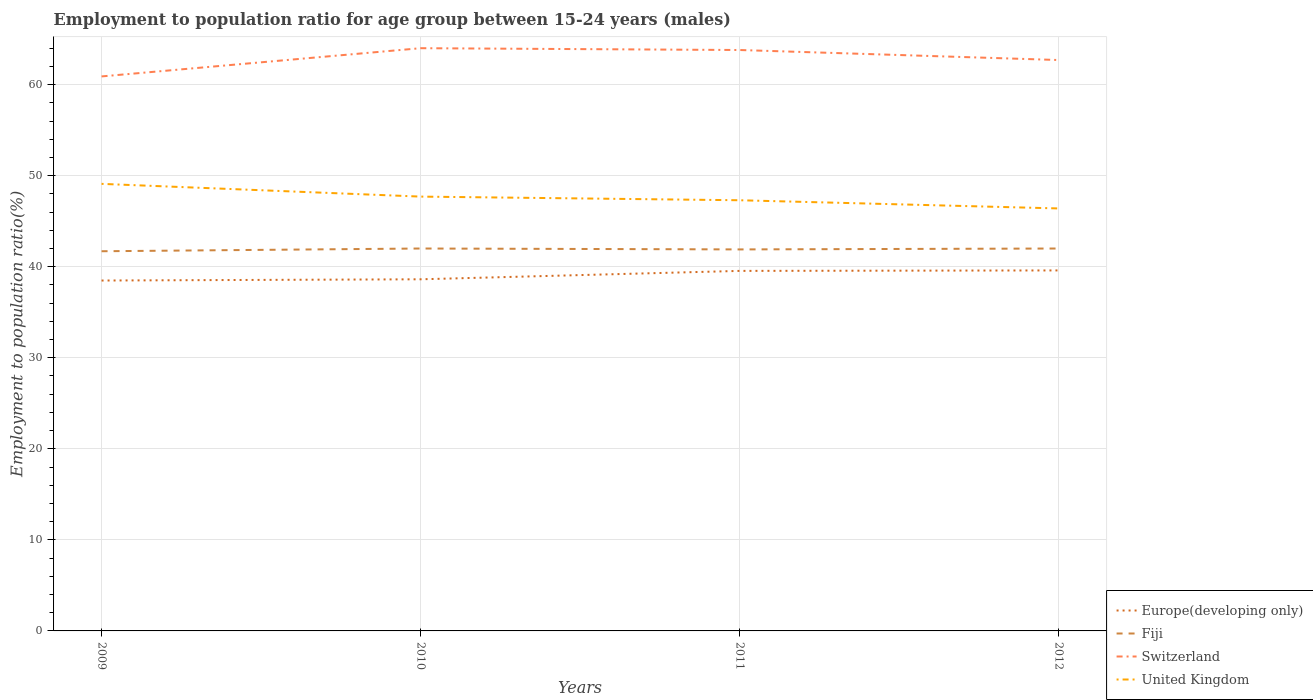Does the line corresponding to Switzerland intersect with the line corresponding to Fiji?
Your answer should be very brief. No. Across all years, what is the maximum employment to population ratio in Europe(developing only)?
Provide a succinct answer. 38.48. In which year was the employment to population ratio in Fiji maximum?
Keep it short and to the point. 2009. What is the total employment to population ratio in Europe(developing only) in the graph?
Give a very brief answer. -0.97. What is the difference between the highest and the second highest employment to population ratio in Fiji?
Your answer should be compact. 0.3. What is the difference between the highest and the lowest employment to population ratio in United Kingdom?
Offer a very short reply. 2. Are the values on the major ticks of Y-axis written in scientific E-notation?
Offer a very short reply. No. Does the graph contain grids?
Give a very brief answer. Yes. How are the legend labels stacked?
Your response must be concise. Vertical. What is the title of the graph?
Make the answer very short. Employment to population ratio for age group between 15-24 years (males). Does "Bolivia" appear as one of the legend labels in the graph?
Ensure brevity in your answer.  No. What is the label or title of the X-axis?
Offer a very short reply. Years. What is the Employment to population ratio(%) of Europe(developing only) in 2009?
Provide a succinct answer. 38.48. What is the Employment to population ratio(%) in Fiji in 2009?
Your answer should be very brief. 41.7. What is the Employment to population ratio(%) in Switzerland in 2009?
Give a very brief answer. 60.9. What is the Employment to population ratio(%) of United Kingdom in 2009?
Provide a short and direct response. 49.1. What is the Employment to population ratio(%) of Europe(developing only) in 2010?
Provide a succinct answer. 38.62. What is the Employment to population ratio(%) in Switzerland in 2010?
Make the answer very short. 64. What is the Employment to population ratio(%) in United Kingdom in 2010?
Keep it short and to the point. 47.7. What is the Employment to population ratio(%) of Europe(developing only) in 2011?
Ensure brevity in your answer.  39.54. What is the Employment to population ratio(%) in Fiji in 2011?
Give a very brief answer. 41.9. What is the Employment to population ratio(%) of Switzerland in 2011?
Offer a terse response. 63.8. What is the Employment to population ratio(%) of United Kingdom in 2011?
Your answer should be very brief. 47.3. What is the Employment to population ratio(%) in Europe(developing only) in 2012?
Provide a short and direct response. 39.59. What is the Employment to population ratio(%) in Fiji in 2012?
Keep it short and to the point. 42. What is the Employment to population ratio(%) of Switzerland in 2012?
Give a very brief answer. 62.7. What is the Employment to population ratio(%) in United Kingdom in 2012?
Make the answer very short. 46.4. Across all years, what is the maximum Employment to population ratio(%) of Europe(developing only)?
Ensure brevity in your answer.  39.59. Across all years, what is the maximum Employment to population ratio(%) of Switzerland?
Offer a very short reply. 64. Across all years, what is the maximum Employment to population ratio(%) of United Kingdom?
Provide a short and direct response. 49.1. Across all years, what is the minimum Employment to population ratio(%) of Europe(developing only)?
Ensure brevity in your answer.  38.48. Across all years, what is the minimum Employment to population ratio(%) in Fiji?
Your answer should be compact. 41.7. Across all years, what is the minimum Employment to population ratio(%) of Switzerland?
Give a very brief answer. 60.9. Across all years, what is the minimum Employment to population ratio(%) in United Kingdom?
Give a very brief answer. 46.4. What is the total Employment to population ratio(%) of Europe(developing only) in the graph?
Offer a very short reply. 156.24. What is the total Employment to population ratio(%) of Fiji in the graph?
Your response must be concise. 167.6. What is the total Employment to population ratio(%) in Switzerland in the graph?
Provide a succinct answer. 251.4. What is the total Employment to population ratio(%) in United Kingdom in the graph?
Your answer should be compact. 190.5. What is the difference between the Employment to population ratio(%) in Europe(developing only) in 2009 and that in 2010?
Your answer should be very brief. -0.14. What is the difference between the Employment to population ratio(%) of Fiji in 2009 and that in 2010?
Offer a very short reply. -0.3. What is the difference between the Employment to population ratio(%) in Switzerland in 2009 and that in 2010?
Keep it short and to the point. -3.1. What is the difference between the Employment to population ratio(%) in Europe(developing only) in 2009 and that in 2011?
Provide a succinct answer. -1.06. What is the difference between the Employment to population ratio(%) in Fiji in 2009 and that in 2011?
Make the answer very short. -0.2. What is the difference between the Employment to population ratio(%) in Switzerland in 2009 and that in 2011?
Your answer should be very brief. -2.9. What is the difference between the Employment to population ratio(%) of United Kingdom in 2009 and that in 2011?
Make the answer very short. 1.8. What is the difference between the Employment to population ratio(%) of Europe(developing only) in 2009 and that in 2012?
Ensure brevity in your answer.  -1.11. What is the difference between the Employment to population ratio(%) of Fiji in 2009 and that in 2012?
Your response must be concise. -0.3. What is the difference between the Employment to population ratio(%) of Europe(developing only) in 2010 and that in 2011?
Provide a succinct answer. -0.92. What is the difference between the Employment to population ratio(%) in Fiji in 2010 and that in 2011?
Ensure brevity in your answer.  0.1. What is the difference between the Employment to population ratio(%) of Switzerland in 2010 and that in 2011?
Your answer should be compact. 0.2. What is the difference between the Employment to population ratio(%) of Europe(developing only) in 2010 and that in 2012?
Offer a terse response. -0.97. What is the difference between the Employment to population ratio(%) of United Kingdom in 2010 and that in 2012?
Offer a very short reply. 1.3. What is the difference between the Employment to population ratio(%) in Europe(developing only) in 2011 and that in 2012?
Your answer should be compact. -0.05. What is the difference between the Employment to population ratio(%) of United Kingdom in 2011 and that in 2012?
Make the answer very short. 0.9. What is the difference between the Employment to population ratio(%) of Europe(developing only) in 2009 and the Employment to population ratio(%) of Fiji in 2010?
Your response must be concise. -3.52. What is the difference between the Employment to population ratio(%) in Europe(developing only) in 2009 and the Employment to population ratio(%) in Switzerland in 2010?
Provide a succinct answer. -25.52. What is the difference between the Employment to population ratio(%) in Europe(developing only) in 2009 and the Employment to population ratio(%) in United Kingdom in 2010?
Offer a terse response. -9.22. What is the difference between the Employment to population ratio(%) in Fiji in 2009 and the Employment to population ratio(%) in Switzerland in 2010?
Provide a short and direct response. -22.3. What is the difference between the Employment to population ratio(%) of Fiji in 2009 and the Employment to population ratio(%) of United Kingdom in 2010?
Make the answer very short. -6. What is the difference between the Employment to population ratio(%) of Europe(developing only) in 2009 and the Employment to population ratio(%) of Fiji in 2011?
Ensure brevity in your answer.  -3.42. What is the difference between the Employment to population ratio(%) in Europe(developing only) in 2009 and the Employment to population ratio(%) in Switzerland in 2011?
Your answer should be compact. -25.32. What is the difference between the Employment to population ratio(%) in Europe(developing only) in 2009 and the Employment to population ratio(%) in United Kingdom in 2011?
Provide a succinct answer. -8.82. What is the difference between the Employment to population ratio(%) in Fiji in 2009 and the Employment to population ratio(%) in Switzerland in 2011?
Ensure brevity in your answer.  -22.1. What is the difference between the Employment to population ratio(%) of Fiji in 2009 and the Employment to population ratio(%) of United Kingdom in 2011?
Make the answer very short. -5.6. What is the difference between the Employment to population ratio(%) of Europe(developing only) in 2009 and the Employment to population ratio(%) of Fiji in 2012?
Your answer should be very brief. -3.52. What is the difference between the Employment to population ratio(%) of Europe(developing only) in 2009 and the Employment to population ratio(%) of Switzerland in 2012?
Provide a succinct answer. -24.22. What is the difference between the Employment to population ratio(%) of Europe(developing only) in 2009 and the Employment to population ratio(%) of United Kingdom in 2012?
Your answer should be compact. -7.92. What is the difference between the Employment to population ratio(%) in Fiji in 2009 and the Employment to population ratio(%) in United Kingdom in 2012?
Your answer should be very brief. -4.7. What is the difference between the Employment to population ratio(%) in Europe(developing only) in 2010 and the Employment to population ratio(%) in Fiji in 2011?
Provide a succinct answer. -3.28. What is the difference between the Employment to population ratio(%) in Europe(developing only) in 2010 and the Employment to population ratio(%) in Switzerland in 2011?
Your answer should be compact. -25.18. What is the difference between the Employment to population ratio(%) of Europe(developing only) in 2010 and the Employment to population ratio(%) of United Kingdom in 2011?
Offer a very short reply. -8.68. What is the difference between the Employment to population ratio(%) of Fiji in 2010 and the Employment to population ratio(%) of Switzerland in 2011?
Give a very brief answer. -21.8. What is the difference between the Employment to population ratio(%) of Europe(developing only) in 2010 and the Employment to population ratio(%) of Fiji in 2012?
Make the answer very short. -3.38. What is the difference between the Employment to population ratio(%) of Europe(developing only) in 2010 and the Employment to population ratio(%) of Switzerland in 2012?
Make the answer very short. -24.08. What is the difference between the Employment to population ratio(%) in Europe(developing only) in 2010 and the Employment to population ratio(%) in United Kingdom in 2012?
Keep it short and to the point. -7.78. What is the difference between the Employment to population ratio(%) of Fiji in 2010 and the Employment to population ratio(%) of Switzerland in 2012?
Your answer should be compact. -20.7. What is the difference between the Employment to population ratio(%) in Europe(developing only) in 2011 and the Employment to population ratio(%) in Fiji in 2012?
Offer a terse response. -2.46. What is the difference between the Employment to population ratio(%) in Europe(developing only) in 2011 and the Employment to population ratio(%) in Switzerland in 2012?
Give a very brief answer. -23.16. What is the difference between the Employment to population ratio(%) in Europe(developing only) in 2011 and the Employment to population ratio(%) in United Kingdom in 2012?
Give a very brief answer. -6.86. What is the difference between the Employment to population ratio(%) in Fiji in 2011 and the Employment to population ratio(%) in Switzerland in 2012?
Ensure brevity in your answer.  -20.8. What is the average Employment to population ratio(%) in Europe(developing only) per year?
Your answer should be compact. 39.06. What is the average Employment to population ratio(%) in Fiji per year?
Your answer should be very brief. 41.9. What is the average Employment to population ratio(%) of Switzerland per year?
Your answer should be very brief. 62.85. What is the average Employment to population ratio(%) in United Kingdom per year?
Offer a very short reply. 47.62. In the year 2009, what is the difference between the Employment to population ratio(%) in Europe(developing only) and Employment to population ratio(%) in Fiji?
Provide a succinct answer. -3.22. In the year 2009, what is the difference between the Employment to population ratio(%) in Europe(developing only) and Employment to population ratio(%) in Switzerland?
Keep it short and to the point. -22.42. In the year 2009, what is the difference between the Employment to population ratio(%) in Europe(developing only) and Employment to population ratio(%) in United Kingdom?
Make the answer very short. -10.62. In the year 2009, what is the difference between the Employment to population ratio(%) of Fiji and Employment to population ratio(%) of Switzerland?
Your response must be concise. -19.2. In the year 2009, what is the difference between the Employment to population ratio(%) in Fiji and Employment to population ratio(%) in United Kingdom?
Ensure brevity in your answer.  -7.4. In the year 2010, what is the difference between the Employment to population ratio(%) in Europe(developing only) and Employment to population ratio(%) in Fiji?
Your answer should be compact. -3.38. In the year 2010, what is the difference between the Employment to population ratio(%) of Europe(developing only) and Employment to population ratio(%) of Switzerland?
Ensure brevity in your answer.  -25.38. In the year 2010, what is the difference between the Employment to population ratio(%) in Europe(developing only) and Employment to population ratio(%) in United Kingdom?
Your response must be concise. -9.08. In the year 2010, what is the difference between the Employment to population ratio(%) of Fiji and Employment to population ratio(%) of United Kingdom?
Your response must be concise. -5.7. In the year 2011, what is the difference between the Employment to population ratio(%) of Europe(developing only) and Employment to population ratio(%) of Fiji?
Your response must be concise. -2.36. In the year 2011, what is the difference between the Employment to population ratio(%) in Europe(developing only) and Employment to population ratio(%) in Switzerland?
Make the answer very short. -24.26. In the year 2011, what is the difference between the Employment to population ratio(%) of Europe(developing only) and Employment to population ratio(%) of United Kingdom?
Your answer should be very brief. -7.76. In the year 2011, what is the difference between the Employment to population ratio(%) of Fiji and Employment to population ratio(%) of Switzerland?
Your answer should be very brief. -21.9. In the year 2011, what is the difference between the Employment to population ratio(%) of Switzerland and Employment to population ratio(%) of United Kingdom?
Your response must be concise. 16.5. In the year 2012, what is the difference between the Employment to population ratio(%) in Europe(developing only) and Employment to population ratio(%) in Fiji?
Offer a very short reply. -2.41. In the year 2012, what is the difference between the Employment to population ratio(%) in Europe(developing only) and Employment to population ratio(%) in Switzerland?
Keep it short and to the point. -23.11. In the year 2012, what is the difference between the Employment to population ratio(%) in Europe(developing only) and Employment to population ratio(%) in United Kingdom?
Give a very brief answer. -6.81. In the year 2012, what is the difference between the Employment to population ratio(%) in Fiji and Employment to population ratio(%) in Switzerland?
Give a very brief answer. -20.7. What is the ratio of the Employment to population ratio(%) in Switzerland in 2009 to that in 2010?
Ensure brevity in your answer.  0.95. What is the ratio of the Employment to population ratio(%) in United Kingdom in 2009 to that in 2010?
Provide a succinct answer. 1.03. What is the ratio of the Employment to population ratio(%) of Europe(developing only) in 2009 to that in 2011?
Provide a succinct answer. 0.97. What is the ratio of the Employment to population ratio(%) of Fiji in 2009 to that in 2011?
Your answer should be very brief. 1. What is the ratio of the Employment to population ratio(%) of Switzerland in 2009 to that in 2011?
Offer a very short reply. 0.95. What is the ratio of the Employment to population ratio(%) in United Kingdom in 2009 to that in 2011?
Provide a succinct answer. 1.04. What is the ratio of the Employment to population ratio(%) in Europe(developing only) in 2009 to that in 2012?
Keep it short and to the point. 0.97. What is the ratio of the Employment to population ratio(%) of Switzerland in 2009 to that in 2012?
Offer a very short reply. 0.97. What is the ratio of the Employment to population ratio(%) in United Kingdom in 2009 to that in 2012?
Offer a terse response. 1.06. What is the ratio of the Employment to population ratio(%) of Europe(developing only) in 2010 to that in 2011?
Ensure brevity in your answer.  0.98. What is the ratio of the Employment to population ratio(%) in Fiji in 2010 to that in 2011?
Provide a succinct answer. 1. What is the ratio of the Employment to population ratio(%) of United Kingdom in 2010 to that in 2011?
Your answer should be very brief. 1.01. What is the ratio of the Employment to population ratio(%) of Europe(developing only) in 2010 to that in 2012?
Offer a terse response. 0.98. What is the ratio of the Employment to population ratio(%) in Switzerland in 2010 to that in 2012?
Ensure brevity in your answer.  1.02. What is the ratio of the Employment to population ratio(%) of United Kingdom in 2010 to that in 2012?
Your answer should be very brief. 1.03. What is the ratio of the Employment to population ratio(%) in Fiji in 2011 to that in 2012?
Give a very brief answer. 1. What is the ratio of the Employment to population ratio(%) of Switzerland in 2011 to that in 2012?
Your answer should be compact. 1.02. What is the ratio of the Employment to population ratio(%) in United Kingdom in 2011 to that in 2012?
Offer a terse response. 1.02. What is the difference between the highest and the second highest Employment to population ratio(%) in Europe(developing only)?
Your response must be concise. 0.05. What is the difference between the highest and the second highest Employment to population ratio(%) in Fiji?
Give a very brief answer. 0. What is the difference between the highest and the lowest Employment to population ratio(%) in Europe(developing only)?
Make the answer very short. 1.11. What is the difference between the highest and the lowest Employment to population ratio(%) of United Kingdom?
Your answer should be very brief. 2.7. 